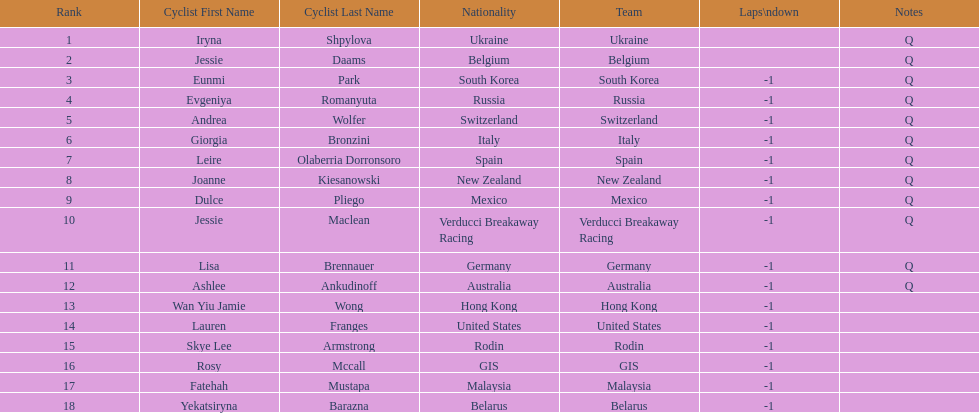How many consecutive notes are there? 12. 